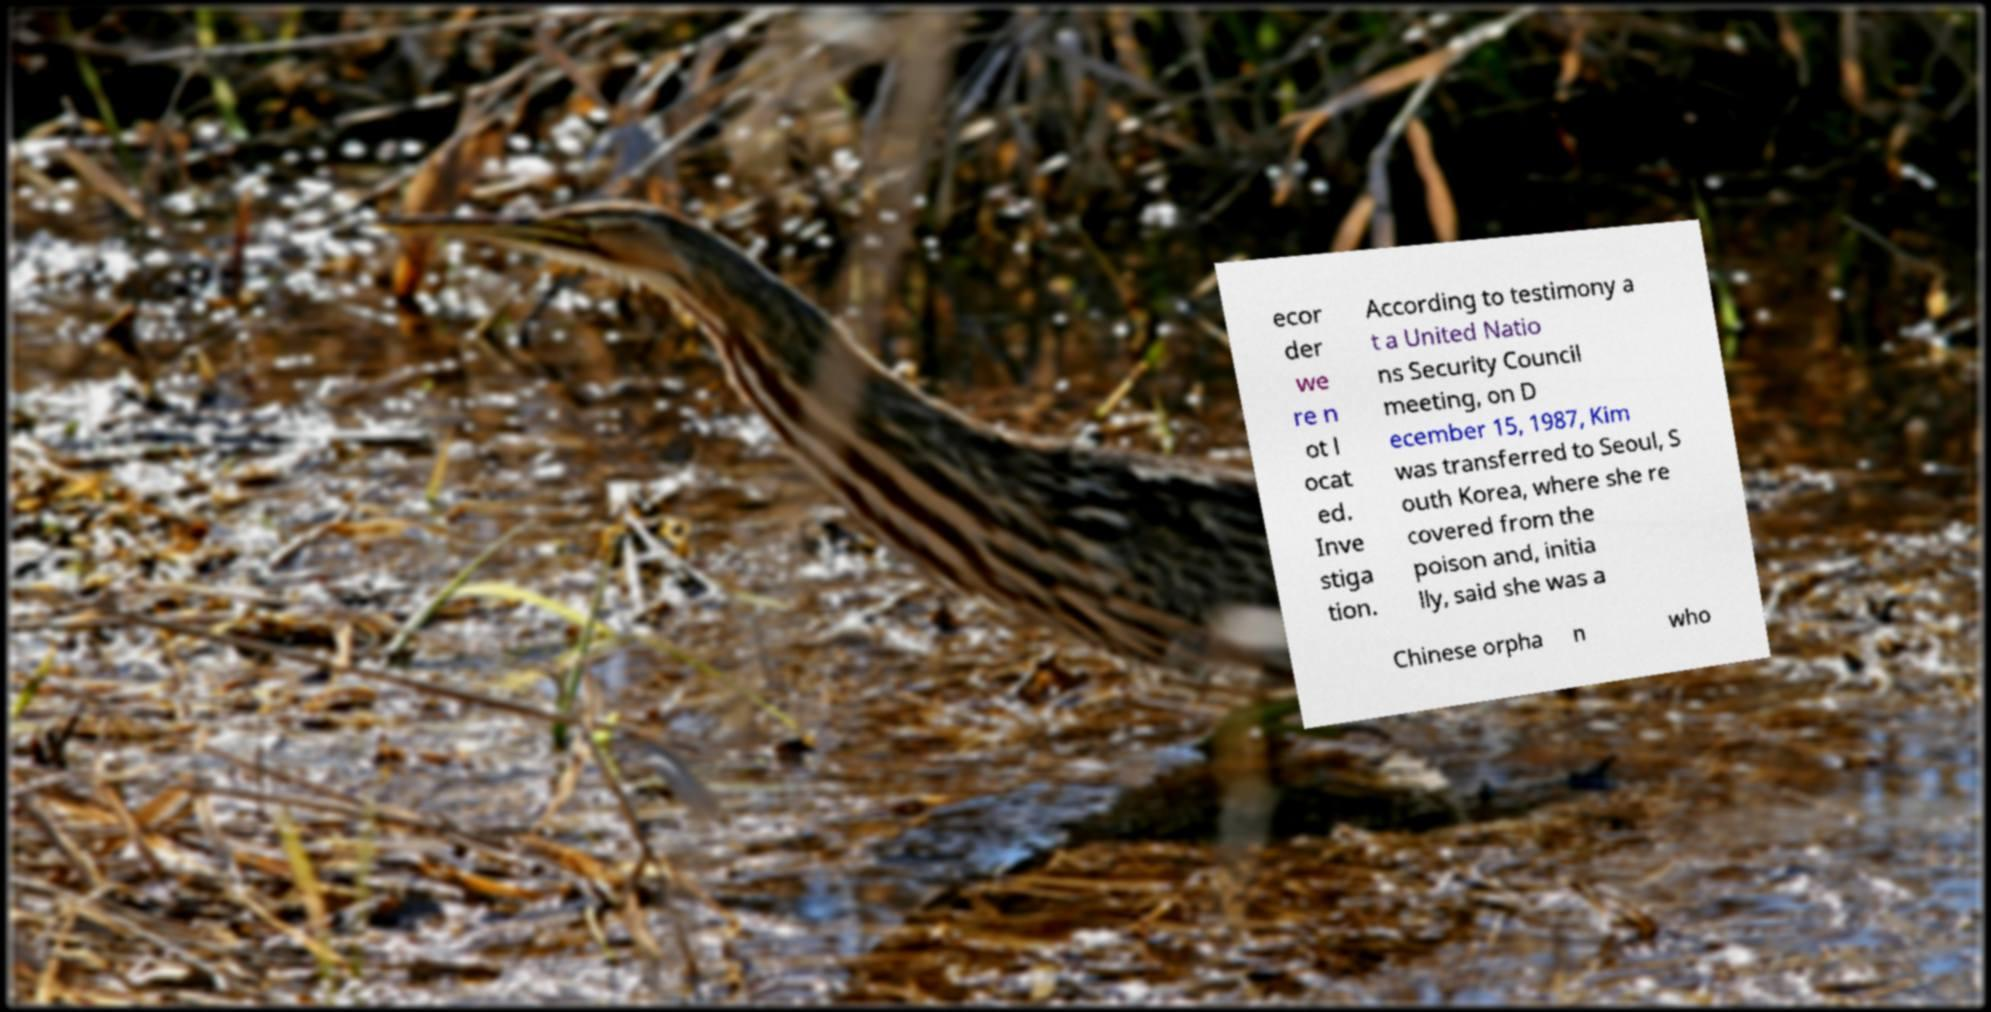Can you accurately transcribe the text from the provided image for me? ecor der we re n ot l ocat ed. Inve stiga tion. According to testimony a t a United Natio ns Security Council meeting, on D ecember 15, 1987, Kim was transferred to Seoul, S outh Korea, where she re covered from the poison and, initia lly, said she was a Chinese orpha n who 